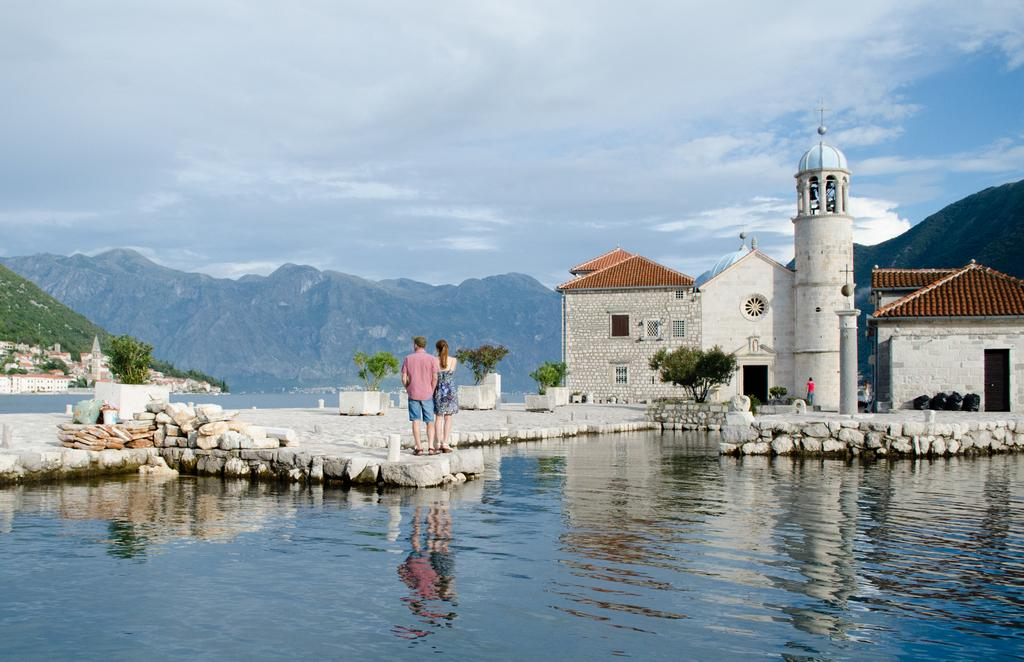How many people are present in the image? There are two persons standing in the image. What is visible in the image besides the people? Water, stones, trees, stone houses, hills, and a cloudy sky are visible in the image. What type of structures can be seen in the image? Stone houses are present in the image. What is the weather like in the image? The sky is cloudy in the background of the image, suggesting a potentially overcast or rainy day. What type of sound can be heard coming from the hole in the image? There is no hole present in the image, so it is not possible to determine what, if any, sound might be heard. 